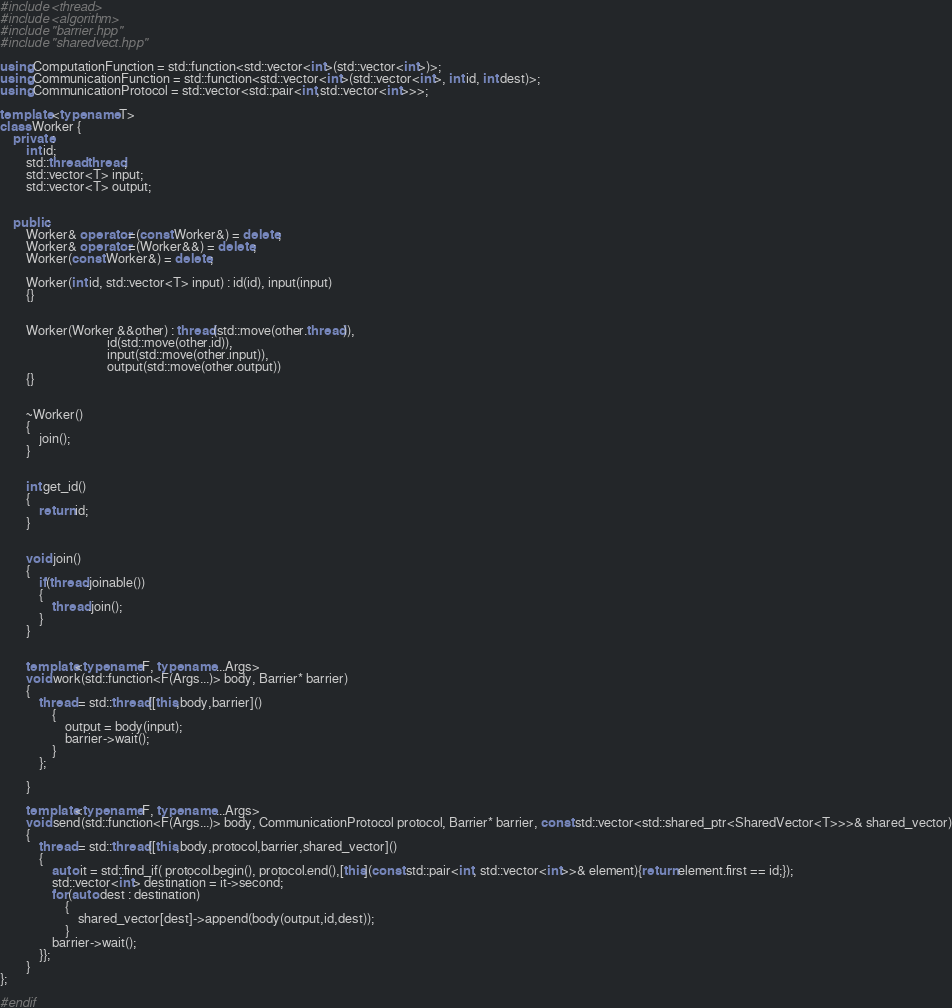<code> <loc_0><loc_0><loc_500><loc_500><_C++_>#include <thread>
#include <algorithm>
#include "barrier.hpp"
#include "sharedvect.hpp"

using ComputationFunction = std::function<std::vector<int>(std::vector<int>)>;
using CommunicationFunction = std::function<std::vector<int>(std::vector<int>, int id, int dest)>;
using CommunicationProtocol = std::vector<std::pair<int,std::vector<int>>>;

template <typename T>
class Worker {
    private:
        int id;
        std::thread thread;
        std::vector<T> input;
        std::vector<T> output;


    public:
        Worker& operator=(const Worker&) = delete; 
        Worker& operator=(Worker&&) = delete;
        Worker(const Worker&) = delete;

        Worker(int id, std::vector<T> input) : id(id), input(input)
        {}


        Worker(Worker &&other) : thread(std::move(other.thread)),
                                 id(std::move(other.id)),
                                 input(std::move(other.input)),
                                 output(std::move(other.output))
        {}

        
        ~Worker()
        {
            join();
        }


        int get_id()
        {
            return id;    
        }


        void join()
        {
            if(thread.joinable())
            {
                thread.join();
            }
        }


        template<typename F, typename ...Args>
        void work(std::function<F(Args...)> body, Barrier* barrier)
        {
            thread = std::thread{[this,body,barrier]()
                { 
                    output = body(input);
                    barrier->wait();
                }
            };

        }
        
        template<typename F, typename ...Args>
        void send(std::function<F(Args...)> body, CommunicationProtocol protocol, Barrier* barrier, const std::vector<std::shared_ptr<SharedVector<T>>>& shared_vector)
        {
            thread = std::thread{[this,body,protocol,barrier,shared_vector]()
            { 
                auto it = std::find_if( protocol.begin(), protocol.end(),[this](const std::pair<int, std::vector<int>>& element){return element.first == id;});
                std::vector<int> destination = it->second;
                for(auto dest : destination)
                    {
                        shared_vector[dest]->append(body(output,id,dest));
                    }
                barrier->wait();
            }};
        }
};

#endif
</code> 